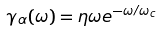<formula> <loc_0><loc_0><loc_500><loc_500>\gamma _ { \alpha } ( \omega ) = \eta \omega e ^ { - \omega / \omega _ { c } }</formula> 